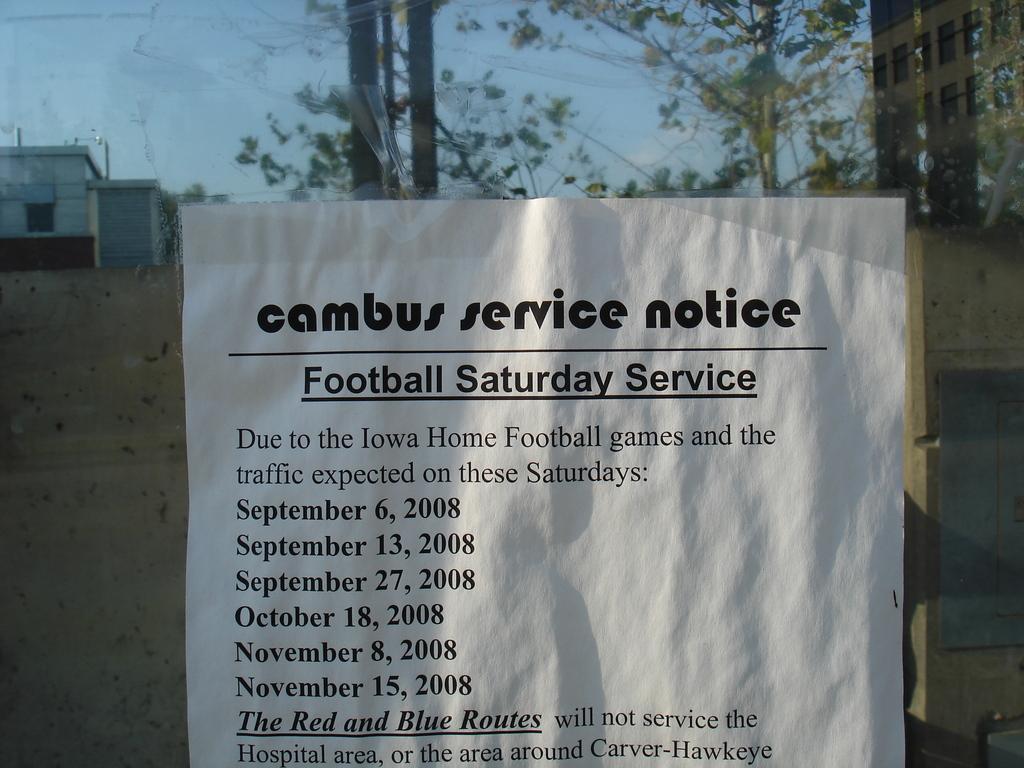Please provide a concise description of this image. In this picture there is a notice in the center of the image and there are buildings and trees in the background area of the image. 